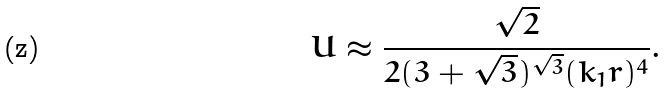<formula> <loc_0><loc_0><loc_500><loc_500>U \approx \frac { \sqrt { 2 } } { 2 ( 3 + \sqrt { 3 } ) ^ { \sqrt { 3 } } ( k _ { 1 } r ) ^ { 4 } } .</formula> 